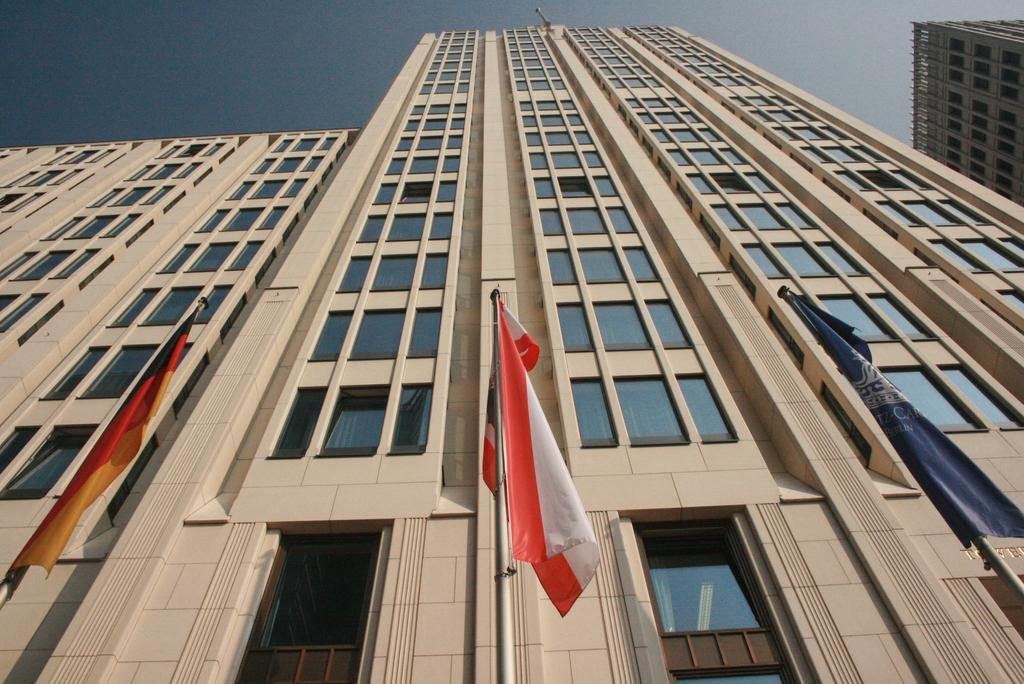What is located in the foreground of the picture? There are flags in the foreground of the picture. What can be seen in the middle of the picture? There are buildings in the middle of the picture. What is visible at the top of the picture? The sky is visible at the top of the picture. What type of discussion is taking place between the father and the brick in the image? There is no father or brick present in the image, so no such discussion can be observed. 